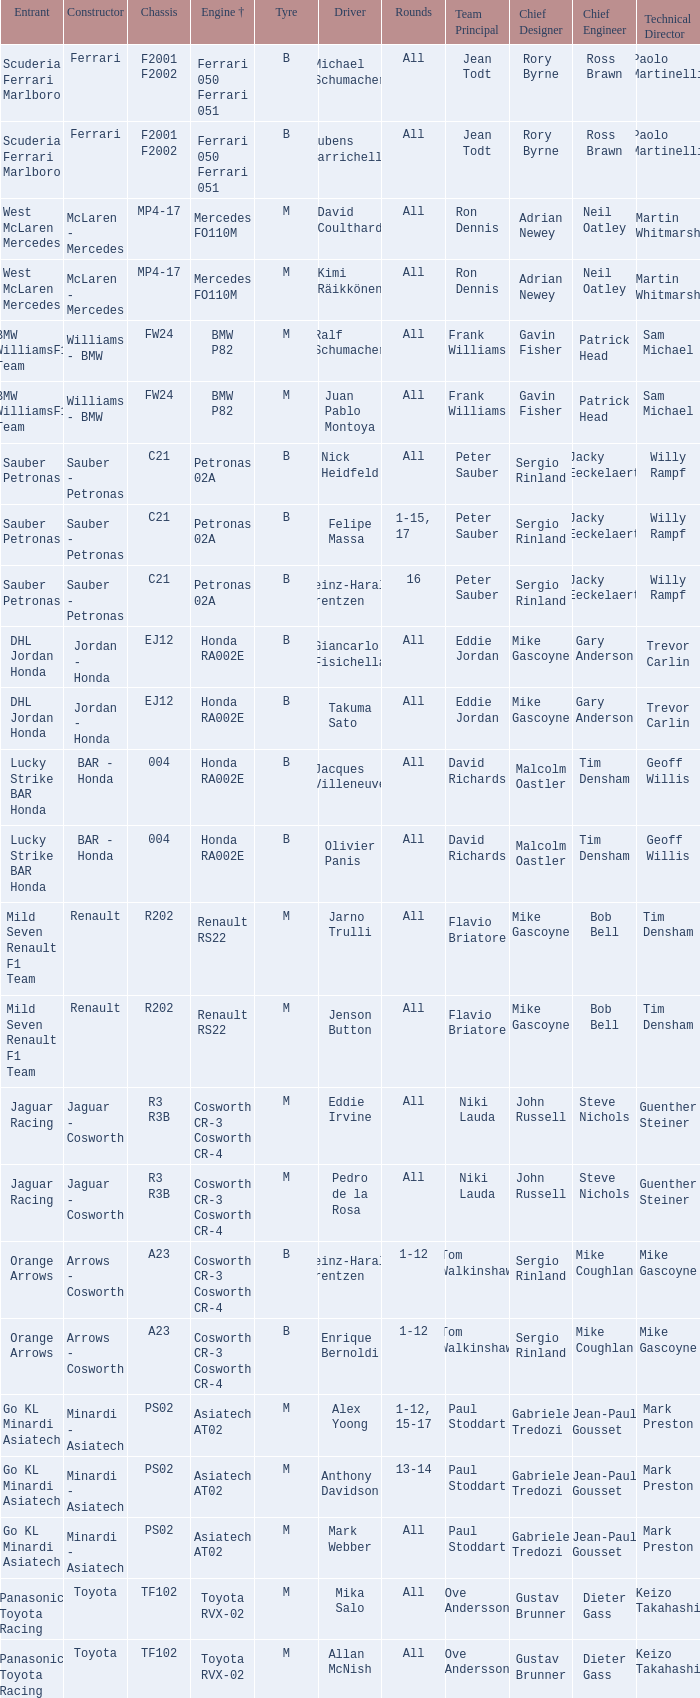Who is the entrant when the engine is bmw p82? BMW WilliamsF1 Team, BMW WilliamsF1 Team. 